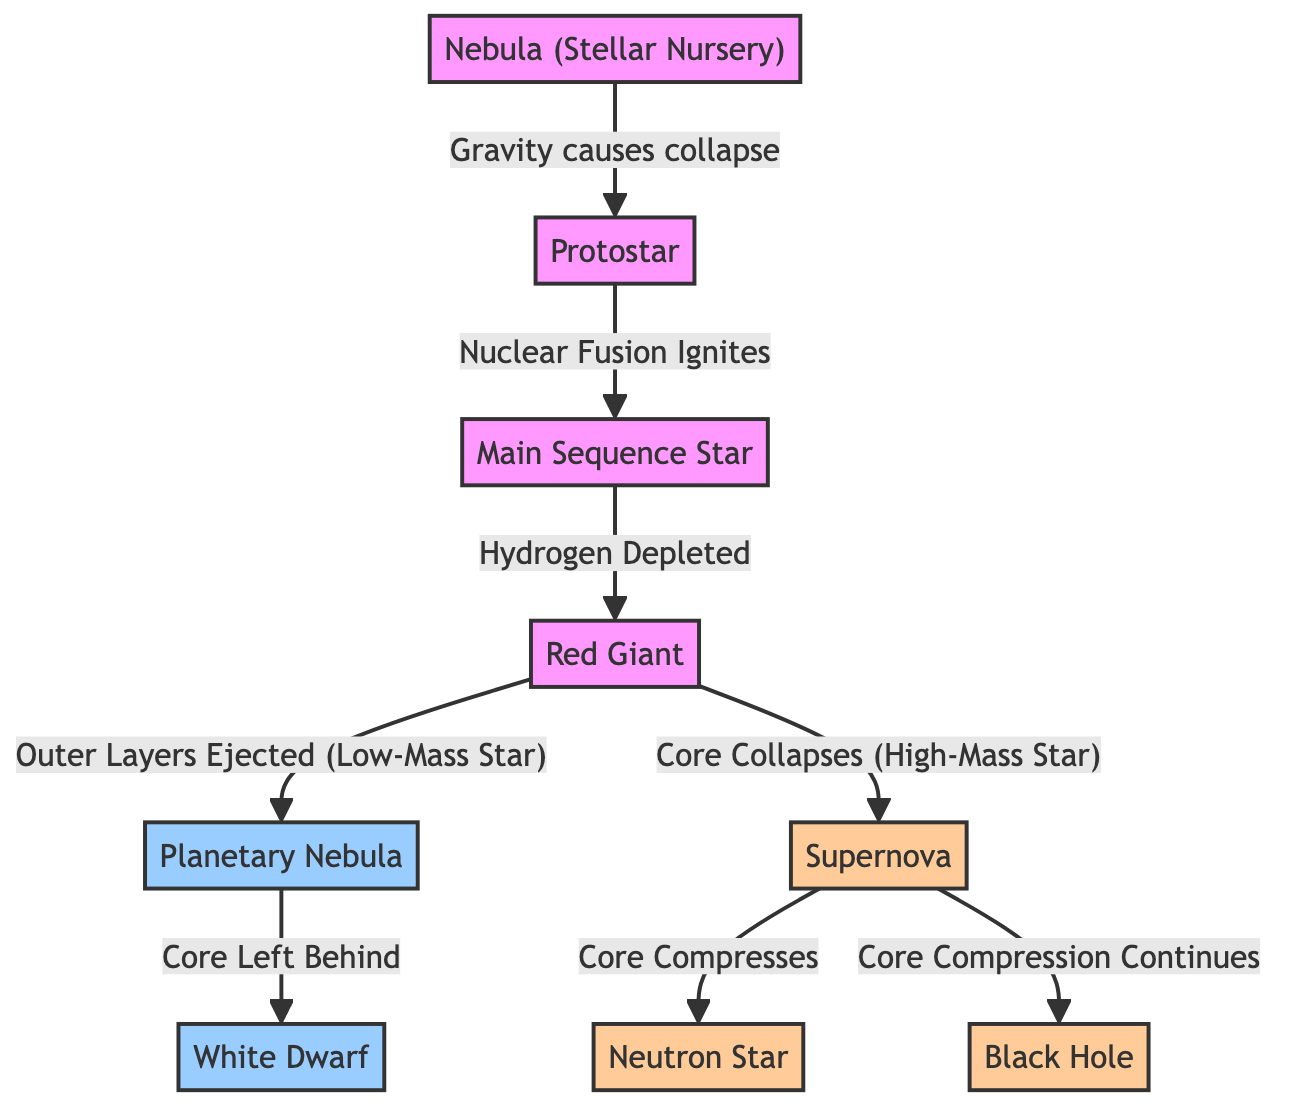What is the first stage in the lifecycle of a star? The diagram starts with the "Nebula (Stellar Nursery)" as the first stage, which is indicated by the first node before any arrows point to it.
Answer: Nebula (Stellar Nursery) What happens after the protostar stage? The protostar is connected by an arrow to the "Main Sequence Star," which shows that this is the next stage in the lifecycle of a star.
Answer: Main Sequence Star How many major stages are there in the lifecycle of a star? By counting the distinct major stages depicted in the diagram, which includes the nebula, protostar, main sequence, red giant, planetary nebula, white dwarf, supernova, neutron star, and black hole, a total of eight stages can be identified.
Answer: 8 What is created after a red giant stage for a low-mass star? The diagram indicates that a low-mass star, after becoming a red giant, ejects its outer layers to form a "Planetary Nebula." This is highlighted by the labeled arrow indicating this transition.
Answer: Planetary Nebula What are the two outcomes after a supernova? The diagram shows two separate paths emerging from the "Supernova" stage, one leading to a "Neutron Star" and the other leading to a "Black Hole." By observing the edges, it's clear that both outcomes are distinctly labeled.
Answer: Neutron Star, Black Hole What initiates the transition from nebula to protostar? The transition from the "Nebula (Stellar Nursery)" to the "Protostar" is initiated by the force of gravity, as stated in the diagram. This transition is marked by an arrow labeled with "Gravity causes collapse."
Answer: Gravity causes collapse Which star type experiences core collapse during the supernova stage? The diagram specifically indicates that only high-mass stars undergo core collapse during the supernova stage, as shown by the class distinction marked in the diagram.
Answer: High-Mass Star What happens to the core of a low-mass star after the planetary nebula? After the planetary nebula formation, the core left behind leads to the creation of a "White Dwarf," as illustrated by the arrow from "Planetary Nebula" to "White Dwarf."
Answer: White Dwarf 